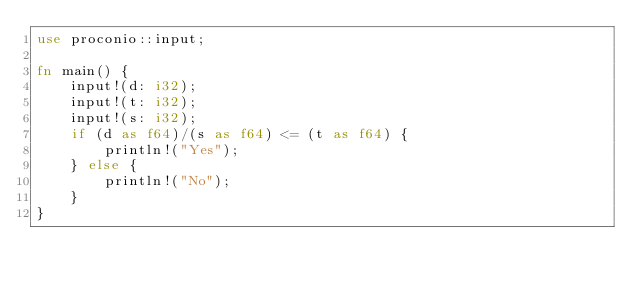Convert code to text. <code><loc_0><loc_0><loc_500><loc_500><_Rust_>use proconio::input;

fn main() {
    input!(d: i32);
    input!(t: i32);
    input!(s: i32);
    if (d as f64)/(s as f64) <= (t as f64) {
        println!("Yes");
    } else {
        println!("No");
    }
}</code> 